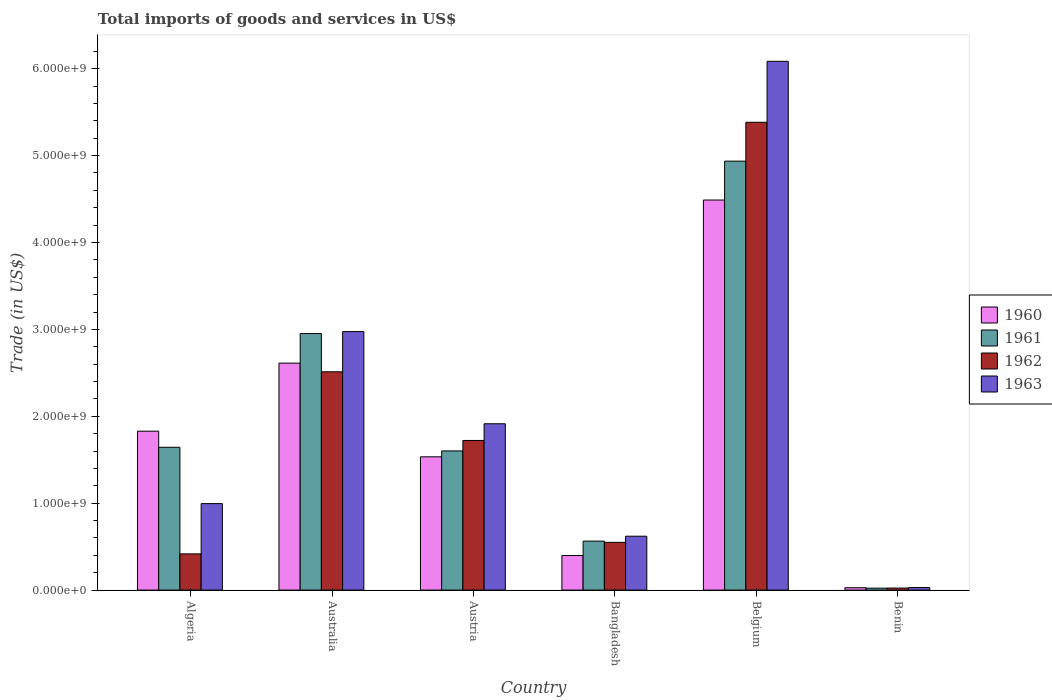How many different coloured bars are there?
Provide a short and direct response. 4. How many bars are there on the 3rd tick from the left?
Offer a very short reply. 4. In how many cases, is the number of bars for a given country not equal to the number of legend labels?
Your answer should be very brief. 0. What is the total imports of goods and services in 1961 in Belgium?
Your answer should be very brief. 4.94e+09. Across all countries, what is the maximum total imports of goods and services in 1960?
Your answer should be compact. 4.49e+09. Across all countries, what is the minimum total imports of goods and services in 1962?
Make the answer very short. 2.35e+07. In which country was the total imports of goods and services in 1963 minimum?
Ensure brevity in your answer.  Benin. What is the total total imports of goods and services in 1962 in the graph?
Provide a succinct answer. 1.06e+1. What is the difference between the total imports of goods and services in 1962 in Austria and that in Bangladesh?
Ensure brevity in your answer.  1.17e+09. What is the difference between the total imports of goods and services in 1962 in Australia and the total imports of goods and services in 1960 in Benin?
Ensure brevity in your answer.  2.48e+09. What is the average total imports of goods and services in 1960 per country?
Provide a succinct answer. 1.81e+09. What is the difference between the total imports of goods and services of/in 1961 and total imports of goods and services of/in 1963 in Austria?
Your answer should be compact. -3.13e+08. In how many countries, is the total imports of goods and services in 1961 greater than 2400000000 US$?
Offer a very short reply. 2. What is the ratio of the total imports of goods and services in 1961 in Bangladesh to that in Benin?
Provide a succinct answer. 25.08. Is the total imports of goods and services in 1960 in Austria less than that in Benin?
Provide a short and direct response. No. Is the difference between the total imports of goods and services in 1961 in Bangladesh and Benin greater than the difference between the total imports of goods and services in 1963 in Bangladesh and Benin?
Keep it short and to the point. No. What is the difference between the highest and the second highest total imports of goods and services in 1961?
Provide a succinct answer. -3.29e+09. What is the difference between the highest and the lowest total imports of goods and services in 1960?
Keep it short and to the point. 4.46e+09. Is the sum of the total imports of goods and services in 1963 in Algeria and Benin greater than the maximum total imports of goods and services in 1960 across all countries?
Keep it short and to the point. No. Is it the case that in every country, the sum of the total imports of goods and services in 1961 and total imports of goods and services in 1960 is greater than the sum of total imports of goods and services in 1962 and total imports of goods and services in 1963?
Your answer should be very brief. No. What does the 4th bar from the left in Australia represents?
Make the answer very short. 1963. How many bars are there?
Make the answer very short. 24. How many countries are there in the graph?
Give a very brief answer. 6. Does the graph contain any zero values?
Offer a very short reply. No. How many legend labels are there?
Offer a terse response. 4. How are the legend labels stacked?
Keep it short and to the point. Vertical. What is the title of the graph?
Your answer should be very brief. Total imports of goods and services in US$. Does "1999" appear as one of the legend labels in the graph?
Offer a very short reply. No. What is the label or title of the Y-axis?
Your answer should be very brief. Trade (in US$). What is the Trade (in US$) in 1960 in Algeria?
Give a very brief answer. 1.83e+09. What is the Trade (in US$) in 1961 in Algeria?
Offer a very short reply. 1.64e+09. What is the Trade (in US$) in 1962 in Algeria?
Provide a short and direct response. 4.17e+08. What is the Trade (in US$) in 1963 in Algeria?
Provide a short and direct response. 9.95e+08. What is the Trade (in US$) in 1960 in Australia?
Your response must be concise. 2.61e+09. What is the Trade (in US$) of 1961 in Australia?
Offer a terse response. 2.95e+09. What is the Trade (in US$) in 1962 in Australia?
Ensure brevity in your answer.  2.51e+09. What is the Trade (in US$) in 1963 in Australia?
Give a very brief answer. 2.97e+09. What is the Trade (in US$) in 1960 in Austria?
Keep it short and to the point. 1.53e+09. What is the Trade (in US$) of 1961 in Austria?
Give a very brief answer. 1.60e+09. What is the Trade (in US$) of 1962 in Austria?
Provide a short and direct response. 1.72e+09. What is the Trade (in US$) of 1963 in Austria?
Make the answer very short. 1.91e+09. What is the Trade (in US$) of 1960 in Bangladesh?
Make the answer very short. 3.98e+08. What is the Trade (in US$) in 1961 in Bangladesh?
Offer a very short reply. 5.64e+08. What is the Trade (in US$) of 1962 in Bangladesh?
Your answer should be compact. 5.49e+08. What is the Trade (in US$) in 1963 in Bangladesh?
Ensure brevity in your answer.  6.20e+08. What is the Trade (in US$) of 1960 in Belgium?
Keep it short and to the point. 4.49e+09. What is the Trade (in US$) in 1961 in Belgium?
Provide a short and direct response. 4.94e+09. What is the Trade (in US$) in 1962 in Belgium?
Offer a very short reply. 5.38e+09. What is the Trade (in US$) in 1963 in Belgium?
Give a very brief answer. 6.08e+09. What is the Trade (in US$) in 1960 in Benin?
Make the answer very short. 2.74e+07. What is the Trade (in US$) in 1961 in Benin?
Offer a very short reply. 2.25e+07. What is the Trade (in US$) of 1962 in Benin?
Your answer should be compact. 2.35e+07. What is the Trade (in US$) in 1963 in Benin?
Your response must be concise. 2.95e+07. Across all countries, what is the maximum Trade (in US$) of 1960?
Offer a very short reply. 4.49e+09. Across all countries, what is the maximum Trade (in US$) in 1961?
Keep it short and to the point. 4.94e+09. Across all countries, what is the maximum Trade (in US$) of 1962?
Provide a short and direct response. 5.38e+09. Across all countries, what is the maximum Trade (in US$) of 1963?
Provide a succinct answer. 6.08e+09. Across all countries, what is the minimum Trade (in US$) of 1960?
Provide a succinct answer. 2.74e+07. Across all countries, what is the minimum Trade (in US$) of 1961?
Give a very brief answer. 2.25e+07. Across all countries, what is the minimum Trade (in US$) of 1962?
Ensure brevity in your answer.  2.35e+07. Across all countries, what is the minimum Trade (in US$) of 1963?
Your answer should be compact. 2.95e+07. What is the total Trade (in US$) of 1960 in the graph?
Provide a short and direct response. 1.09e+1. What is the total Trade (in US$) of 1961 in the graph?
Make the answer very short. 1.17e+1. What is the total Trade (in US$) in 1962 in the graph?
Provide a succinct answer. 1.06e+1. What is the total Trade (in US$) of 1963 in the graph?
Offer a terse response. 1.26e+1. What is the difference between the Trade (in US$) of 1960 in Algeria and that in Australia?
Make the answer very short. -7.83e+08. What is the difference between the Trade (in US$) in 1961 in Algeria and that in Australia?
Your answer should be compact. -1.31e+09. What is the difference between the Trade (in US$) in 1962 in Algeria and that in Australia?
Your answer should be compact. -2.10e+09. What is the difference between the Trade (in US$) of 1963 in Algeria and that in Australia?
Ensure brevity in your answer.  -1.98e+09. What is the difference between the Trade (in US$) in 1960 in Algeria and that in Austria?
Keep it short and to the point. 2.95e+08. What is the difference between the Trade (in US$) in 1961 in Algeria and that in Austria?
Make the answer very short. 4.21e+07. What is the difference between the Trade (in US$) of 1962 in Algeria and that in Austria?
Your answer should be compact. -1.31e+09. What is the difference between the Trade (in US$) in 1963 in Algeria and that in Austria?
Provide a succinct answer. -9.19e+08. What is the difference between the Trade (in US$) in 1960 in Algeria and that in Bangladesh?
Offer a terse response. 1.43e+09. What is the difference between the Trade (in US$) in 1961 in Algeria and that in Bangladesh?
Your answer should be very brief. 1.08e+09. What is the difference between the Trade (in US$) of 1962 in Algeria and that in Bangladesh?
Keep it short and to the point. -1.33e+08. What is the difference between the Trade (in US$) in 1963 in Algeria and that in Bangladesh?
Keep it short and to the point. 3.75e+08. What is the difference between the Trade (in US$) of 1960 in Algeria and that in Belgium?
Provide a short and direct response. -2.66e+09. What is the difference between the Trade (in US$) in 1961 in Algeria and that in Belgium?
Provide a succinct answer. -3.29e+09. What is the difference between the Trade (in US$) of 1962 in Algeria and that in Belgium?
Make the answer very short. -4.97e+09. What is the difference between the Trade (in US$) of 1963 in Algeria and that in Belgium?
Make the answer very short. -5.09e+09. What is the difference between the Trade (in US$) in 1960 in Algeria and that in Benin?
Offer a very short reply. 1.80e+09. What is the difference between the Trade (in US$) of 1961 in Algeria and that in Benin?
Offer a very short reply. 1.62e+09. What is the difference between the Trade (in US$) of 1962 in Algeria and that in Benin?
Provide a succinct answer. 3.93e+08. What is the difference between the Trade (in US$) of 1963 in Algeria and that in Benin?
Your answer should be very brief. 9.66e+08. What is the difference between the Trade (in US$) of 1960 in Australia and that in Austria?
Provide a short and direct response. 1.08e+09. What is the difference between the Trade (in US$) in 1961 in Australia and that in Austria?
Keep it short and to the point. 1.35e+09. What is the difference between the Trade (in US$) in 1962 in Australia and that in Austria?
Your response must be concise. 7.90e+08. What is the difference between the Trade (in US$) of 1963 in Australia and that in Austria?
Offer a very short reply. 1.06e+09. What is the difference between the Trade (in US$) of 1960 in Australia and that in Bangladesh?
Offer a very short reply. 2.21e+09. What is the difference between the Trade (in US$) in 1961 in Australia and that in Bangladesh?
Offer a terse response. 2.39e+09. What is the difference between the Trade (in US$) of 1962 in Australia and that in Bangladesh?
Ensure brevity in your answer.  1.96e+09. What is the difference between the Trade (in US$) of 1963 in Australia and that in Bangladesh?
Provide a short and direct response. 2.35e+09. What is the difference between the Trade (in US$) in 1960 in Australia and that in Belgium?
Offer a very short reply. -1.88e+09. What is the difference between the Trade (in US$) of 1961 in Australia and that in Belgium?
Offer a terse response. -1.98e+09. What is the difference between the Trade (in US$) in 1962 in Australia and that in Belgium?
Offer a terse response. -2.87e+09. What is the difference between the Trade (in US$) of 1963 in Australia and that in Belgium?
Offer a terse response. -3.11e+09. What is the difference between the Trade (in US$) in 1960 in Australia and that in Benin?
Your answer should be compact. 2.58e+09. What is the difference between the Trade (in US$) in 1961 in Australia and that in Benin?
Your response must be concise. 2.93e+09. What is the difference between the Trade (in US$) of 1962 in Australia and that in Benin?
Keep it short and to the point. 2.49e+09. What is the difference between the Trade (in US$) of 1963 in Australia and that in Benin?
Offer a terse response. 2.95e+09. What is the difference between the Trade (in US$) in 1960 in Austria and that in Bangladesh?
Your response must be concise. 1.14e+09. What is the difference between the Trade (in US$) of 1961 in Austria and that in Bangladesh?
Offer a terse response. 1.04e+09. What is the difference between the Trade (in US$) in 1962 in Austria and that in Bangladesh?
Your response must be concise. 1.17e+09. What is the difference between the Trade (in US$) of 1963 in Austria and that in Bangladesh?
Your answer should be very brief. 1.29e+09. What is the difference between the Trade (in US$) of 1960 in Austria and that in Belgium?
Ensure brevity in your answer.  -2.96e+09. What is the difference between the Trade (in US$) in 1961 in Austria and that in Belgium?
Offer a very short reply. -3.33e+09. What is the difference between the Trade (in US$) of 1962 in Austria and that in Belgium?
Make the answer very short. -3.66e+09. What is the difference between the Trade (in US$) in 1963 in Austria and that in Belgium?
Offer a terse response. -4.17e+09. What is the difference between the Trade (in US$) of 1960 in Austria and that in Benin?
Provide a short and direct response. 1.51e+09. What is the difference between the Trade (in US$) of 1961 in Austria and that in Benin?
Your response must be concise. 1.58e+09. What is the difference between the Trade (in US$) of 1962 in Austria and that in Benin?
Provide a short and direct response. 1.70e+09. What is the difference between the Trade (in US$) in 1963 in Austria and that in Benin?
Make the answer very short. 1.88e+09. What is the difference between the Trade (in US$) in 1960 in Bangladesh and that in Belgium?
Offer a very short reply. -4.09e+09. What is the difference between the Trade (in US$) of 1961 in Bangladesh and that in Belgium?
Your response must be concise. -4.37e+09. What is the difference between the Trade (in US$) of 1962 in Bangladesh and that in Belgium?
Give a very brief answer. -4.83e+09. What is the difference between the Trade (in US$) of 1963 in Bangladesh and that in Belgium?
Give a very brief answer. -5.46e+09. What is the difference between the Trade (in US$) of 1960 in Bangladesh and that in Benin?
Provide a short and direct response. 3.70e+08. What is the difference between the Trade (in US$) in 1961 in Bangladesh and that in Benin?
Your answer should be compact. 5.41e+08. What is the difference between the Trade (in US$) of 1962 in Bangladesh and that in Benin?
Offer a terse response. 5.26e+08. What is the difference between the Trade (in US$) of 1963 in Bangladesh and that in Benin?
Provide a succinct answer. 5.91e+08. What is the difference between the Trade (in US$) of 1960 in Belgium and that in Benin?
Give a very brief answer. 4.46e+09. What is the difference between the Trade (in US$) of 1961 in Belgium and that in Benin?
Your answer should be very brief. 4.91e+09. What is the difference between the Trade (in US$) in 1962 in Belgium and that in Benin?
Provide a short and direct response. 5.36e+09. What is the difference between the Trade (in US$) of 1963 in Belgium and that in Benin?
Your response must be concise. 6.06e+09. What is the difference between the Trade (in US$) in 1960 in Algeria and the Trade (in US$) in 1961 in Australia?
Provide a succinct answer. -1.12e+09. What is the difference between the Trade (in US$) of 1960 in Algeria and the Trade (in US$) of 1962 in Australia?
Keep it short and to the point. -6.83e+08. What is the difference between the Trade (in US$) of 1960 in Algeria and the Trade (in US$) of 1963 in Australia?
Offer a very short reply. -1.15e+09. What is the difference between the Trade (in US$) in 1961 in Algeria and the Trade (in US$) in 1962 in Australia?
Offer a very short reply. -8.68e+08. What is the difference between the Trade (in US$) in 1961 in Algeria and the Trade (in US$) in 1963 in Australia?
Make the answer very short. -1.33e+09. What is the difference between the Trade (in US$) in 1962 in Algeria and the Trade (in US$) in 1963 in Australia?
Offer a terse response. -2.56e+09. What is the difference between the Trade (in US$) of 1960 in Algeria and the Trade (in US$) of 1961 in Austria?
Make the answer very short. 2.27e+08. What is the difference between the Trade (in US$) of 1960 in Algeria and the Trade (in US$) of 1962 in Austria?
Offer a very short reply. 1.07e+08. What is the difference between the Trade (in US$) in 1960 in Algeria and the Trade (in US$) in 1963 in Austria?
Ensure brevity in your answer.  -8.54e+07. What is the difference between the Trade (in US$) of 1961 in Algeria and the Trade (in US$) of 1962 in Austria?
Provide a short and direct response. -7.84e+07. What is the difference between the Trade (in US$) in 1961 in Algeria and the Trade (in US$) in 1963 in Austria?
Keep it short and to the point. -2.71e+08. What is the difference between the Trade (in US$) of 1962 in Algeria and the Trade (in US$) of 1963 in Austria?
Ensure brevity in your answer.  -1.50e+09. What is the difference between the Trade (in US$) of 1960 in Algeria and the Trade (in US$) of 1961 in Bangladesh?
Offer a very short reply. 1.27e+09. What is the difference between the Trade (in US$) of 1960 in Algeria and the Trade (in US$) of 1962 in Bangladesh?
Your response must be concise. 1.28e+09. What is the difference between the Trade (in US$) in 1960 in Algeria and the Trade (in US$) in 1963 in Bangladesh?
Provide a short and direct response. 1.21e+09. What is the difference between the Trade (in US$) in 1961 in Algeria and the Trade (in US$) in 1962 in Bangladesh?
Give a very brief answer. 1.09e+09. What is the difference between the Trade (in US$) of 1961 in Algeria and the Trade (in US$) of 1963 in Bangladesh?
Keep it short and to the point. 1.02e+09. What is the difference between the Trade (in US$) in 1962 in Algeria and the Trade (in US$) in 1963 in Bangladesh?
Give a very brief answer. -2.03e+08. What is the difference between the Trade (in US$) in 1960 in Algeria and the Trade (in US$) in 1961 in Belgium?
Offer a very short reply. -3.11e+09. What is the difference between the Trade (in US$) of 1960 in Algeria and the Trade (in US$) of 1962 in Belgium?
Offer a very short reply. -3.55e+09. What is the difference between the Trade (in US$) in 1960 in Algeria and the Trade (in US$) in 1963 in Belgium?
Give a very brief answer. -4.26e+09. What is the difference between the Trade (in US$) of 1961 in Algeria and the Trade (in US$) of 1962 in Belgium?
Offer a terse response. -3.74e+09. What is the difference between the Trade (in US$) of 1961 in Algeria and the Trade (in US$) of 1963 in Belgium?
Provide a short and direct response. -4.44e+09. What is the difference between the Trade (in US$) in 1962 in Algeria and the Trade (in US$) in 1963 in Belgium?
Make the answer very short. -5.67e+09. What is the difference between the Trade (in US$) in 1960 in Algeria and the Trade (in US$) in 1961 in Benin?
Your response must be concise. 1.81e+09. What is the difference between the Trade (in US$) in 1960 in Algeria and the Trade (in US$) in 1962 in Benin?
Offer a very short reply. 1.81e+09. What is the difference between the Trade (in US$) of 1960 in Algeria and the Trade (in US$) of 1963 in Benin?
Offer a very short reply. 1.80e+09. What is the difference between the Trade (in US$) in 1961 in Algeria and the Trade (in US$) in 1962 in Benin?
Ensure brevity in your answer.  1.62e+09. What is the difference between the Trade (in US$) in 1961 in Algeria and the Trade (in US$) in 1963 in Benin?
Provide a short and direct response. 1.61e+09. What is the difference between the Trade (in US$) of 1962 in Algeria and the Trade (in US$) of 1963 in Benin?
Offer a very short reply. 3.87e+08. What is the difference between the Trade (in US$) in 1960 in Australia and the Trade (in US$) in 1961 in Austria?
Offer a very short reply. 1.01e+09. What is the difference between the Trade (in US$) in 1960 in Australia and the Trade (in US$) in 1962 in Austria?
Give a very brief answer. 8.90e+08. What is the difference between the Trade (in US$) in 1960 in Australia and the Trade (in US$) in 1963 in Austria?
Your answer should be compact. 6.98e+08. What is the difference between the Trade (in US$) in 1961 in Australia and the Trade (in US$) in 1962 in Austria?
Your answer should be compact. 1.23e+09. What is the difference between the Trade (in US$) of 1961 in Australia and the Trade (in US$) of 1963 in Austria?
Keep it short and to the point. 1.04e+09. What is the difference between the Trade (in US$) in 1962 in Australia and the Trade (in US$) in 1963 in Austria?
Your answer should be very brief. 5.98e+08. What is the difference between the Trade (in US$) in 1960 in Australia and the Trade (in US$) in 1961 in Bangladesh?
Make the answer very short. 2.05e+09. What is the difference between the Trade (in US$) in 1960 in Australia and the Trade (in US$) in 1962 in Bangladesh?
Offer a terse response. 2.06e+09. What is the difference between the Trade (in US$) in 1960 in Australia and the Trade (in US$) in 1963 in Bangladesh?
Offer a terse response. 1.99e+09. What is the difference between the Trade (in US$) of 1961 in Australia and the Trade (in US$) of 1962 in Bangladesh?
Offer a very short reply. 2.40e+09. What is the difference between the Trade (in US$) of 1961 in Australia and the Trade (in US$) of 1963 in Bangladesh?
Your answer should be compact. 2.33e+09. What is the difference between the Trade (in US$) in 1962 in Australia and the Trade (in US$) in 1963 in Bangladesh?
Provide a succinct answer. 1.89e+09. What is the difference between the Trade (in US$) of 1960 in Australia and the Trade (in US$) of 1961 in Belgium?
Offer a very short reply. -2.32e+09. What is the difference between the Trade (in US$) in 1960 in Australia and the Trade (in US$) in 1962 in Belgium?
Ensure brevity in your answer.  -2.77e+09. What is the difference between the Trade (in US$) of 1960 in Australia and the Trade (in US$) of 1963 in Belgium?
Give a very brief answer. -3.47e+09. What is the difference between the Trade (in US$) of 1961 in Australia and the Trade (in US$) of 1962 in Belgium?
Your answer should be compact. -2.43e+09. What is the difference between the Trade (in US$) in 1961 in Australia and the Trade (in US$) in 1963 in Belgium?
Your answer should be compact. -3.13e+09. What is the difference between the Trade (in US$) in 1962 in Australia and the Trade (in US$) in 1963 in Belgium?
Keep it short and to the point. -3.57e+09. What is the difference between the Trade (in US$) of 1960 in Australia and the Trade (in US$) of 1961 in Benin?
Your answer should be compact. 2.59e+09. What is the difference between the Trade (in US$) of 1960 in Australia and the Trade (in US$) of 1962 in Benin?
Your response must be concise. 2.59e+09. What is the difference between the Trade (in US$) of 1960 in Australia and the Trade (in US$) of 1963 in Benin?
Offer a terse response. 2.58e+09. What is the difference between the Trade (in US$) in 1961 in Australia and the Trade (in US$) in 1962 in Benin?
Ensure brevity in your answer.  2.93e+09. What is the difference between the Trade (in US$) in 1961 in Australia and the Trade (in US$) in 1963 in Benin?
Your answer should be very brief. 2.92e+09. What is the difference between the Trade (in US$) in 1962 in Australia and the Trade (in US$) in 1963 in Benin?
Your answer should be very brief. 2.48e+09. What is the difference between the Trade (in US$) in 1960 in Austria and the Trade (in US$) in 1961 in Bangladesh?
Your answer should be compact. 9.70e+08. What is the difference between the Trade (in US$) in 1960 in Austria and the Trade (in US$) in 1962 in Bangladesh?
Keep it short and to the point. 9.84e+08. What is the difference between the Trade (in US$) of 1960 in Austria and the Trade (in US$) of 1963 in Bangladesh?
Your response must be concise. 9.14e+08. What is the difference between the Trade (in US$) in 1961 in Austria and the Trade (in US$) in 1962 in Bangladesh?
Offer a very short reply. 1.05e+09. What is the difference between the Trade (in US$) of 1961 in Austria and the Trade (in US$) of 1963 in Bangladesh?
Your answer should be very brief. 9.81e+08. What is the difference between the Trade (in US$) in 1962 in Austria and the Trade (in US$) in 1963 in Bangladesh?
Your answer should be very brief. 1.10e+09. What is the difference between the Trade (in US$) of 1960 in Austria and the Trade (in US$) of 1961 in Belgium?
Offer a terse response. -3.40e+09. What is the difference between the Trade (in US$) in 1960 in Austria and the Trade (in US$) in 1962 in Belgium?
Your answer should be very brief. -3.85e+09. What is the difference between the Trade (in US$) of 1960 in Austria and the Trade (in US$) of 1963 in Belgium?
Keep it short and to the point. -4.55e+09. What is the difference between the Trade (in US$) in 1961 in Austria and the Trade (in US$) in 1962 in Belgium?
Keep it short and to the point. -3.78e+09. What is the difference between the Trade (in US$) in 1961 in Austria and the Trade (in US$) in 1963 in Belgium?
Provide a succinct answer. -4.48e+09. What is the difference between the Trade (in US$) in 1962 in Austria and the Trade (in US$) in 1963 in Belgium?
Keep it short and to the point. -4.36e+09. What is the difference between the Trade (in US$) in 1960 in Austria and the Trade (in US$) in 1961 in Benin?
Offer a terse response. 1.51e+09. What is the difference between the Trade (in US$) of 1960 in Austria and the Trade (in US$) of 1962 in Benin?
Your answer should be compact. 1.51e+09. What is the difference between the Trade (in US$) of 1960 in Austria and the Trade (in US$) of 1963 in Benin?
Your answer should be very brief. 1.50e+09. What is the difference between the Trade (in US$) in 1961 in Austria and the Trade (in US$) in 1962 in Benin?
Ensure brevity in your answer.  1.58e+09. What is the difference between the Trade (in US$) in 1961 in Austria and the Trade (in US$) in 1963 in Benin?
Offer a terse response. 1.57e+09. What is the difference between the Trade (in US$) of 1962 in Austria and the Trade (in US$) of 1963 in Benin?
Your answer should be compact. 1.69e+09. What is the difference between the Trade (in US$) in 1960 in Bangladesh and the Trade (in US$) in 1961 in Belgium?
Offer a very short reply. -4.54e+09. What is the difference between the Trade (in US$) of 1960 in Bangladesh and the Trade (in US$) of 1962 in Belgium?
Ensure brevity in your answer.  -4.99e+09. What is the difference between the Trade (in US$) in 1960 in Bangladesh and the Trade (in US$) in 1963 in Belgium?
Offer a terse response. -5.69e+09. What is the difference between the Trade (in US$) of 1961 in Bangladesh and the Trade (in US$) of 1962 in Belgium?
Your answer should be compact. -4.82e+09. What is the difference between the Trade (in US$) of 1961 in Bangladesh and the Trade (in US$) of 1963 in Belgium?
Offer a very short reply. -5.52e+09. What is the difference between the Trade (in US$) in 1962 in Bangladesh and the Trade (in US$) in 1963 in Belgium?
Your answer should be compact. -5.54e+09. What is the difference between the Trade (in US$) in 1960 in Bangladesh and the Trade (in US$) in 1961 in Benin?
Give a very brief answer. 3.75e+08. What is the difference between the Trade (in US$) in 1960 in Bangladesh and the Trade (in US$) in 1962 in Benin?
Make the answer very short. 3.74e+08. What is the difference between the Trade (in US$) of 1960 in Bangladesh and the Trade (in US$) of 1963 in Benin?
Your answer should be very brief. 3.68e+08. What is the difference between the Trade (in US$) of 1961 in Bangladesh and the Trade (in US$) of 1962 in Benin?
Offer a very short reply. 5.40e+08. What is the difference between the Trade (in US$) of 1961 in Bangladesh and the Trade (in US$) of 1963 in Benin?
Keep it short and to the point. 5.34e+08. What is the difference between the Trade (in US$) of 1962 in Bangladesh and the Trade (in US$) of 1963 in Benin?
Offer a terse response. 5.20e+08. What is the difference between the Trade (in US$) in 1960 in Belgium and the Trade (in US$) in 1961 in Benin?
Offer a terse response. 4.47e+09. What is the difference between the Trade (in US$) in 1960 in Belgium and the Trade (in US$) in 1962 in Benin?
Your response must be concise. 4.47e+09. What is the difference between the Trade (in US$) in 1960 in Belgium and the Trade (in US$) in 1963 in Benin?
Ensure brevity in your answer.  4.46e+09. What is the difference between the Trade (in US$) of 1961 in Belgium and the Trade (in US$) of 1962 in Benin?
Your response must be concise. 4.91e+09. What is the difference between the Trade (in US$) of 1961 in Belgium and the Trade (in US$) of 1963 in Benin?
Make the answer very short. 4.91e+09. What is the difference between the Trade (in US$) of 1962 in Belgium and the Trade (in US$) of 1963 in Benin?
Offer a terse response. 5.35e+09. What is the average Trade (in US$) of 1960 per country?
Your response must be concise. 1.81e+09. What is the average Trade (in US$) in 1961 per country?
Your answer should be very brief. 1.95e+09. What is the average Trade (in US$) of 1962 per country?
Your response must be concise. 1.77e+09. What is the average Trade (in US$) in 1963 per country?
Provide a short and direct response. 2.10e+09. What is the difference between the Trade (in US$) of 1960 and Trade (in US$) of 1961 in Algeria?
Your answer should be compact. 1.85e+08. What is the difference between the Trade (in US$) in 1960 and Trade (in US$) in 1962 in Algeria?
Ensure brevity in your answer.  1.41e+09. What is the difference between the Trade (in US$) of 1960 and Trade (in US$) of 1963 in Algeria?
Your answer should be compact. 8.33e+08. What is the difference between the Trade (in US$) of 1961 and Trade (in US$) of 1962 in Algeria?
Provide a succinct answer. 1.23e+09. What is the difference between the Trade (in US$) in 1961 and Trade (in US$) in 1963 in Algeria?
Offer a terse response. 6.48e+08. What is the difference between the Trade (in US$) in 1962 and Trade (in US$) in 1963 in Algeria?
Make the answer very short. -5.79e+08. What is the difference between the Trade (in US$) in 1960 and Trade (in US$) in 1961 in Australia?
Offer a very short reply. -3.40e+08. What is the difference between the Trade (in US$) of 1960 and Trade (in US$) of 1962 in Australia?
Give a very brief answer. 9.97e+07. What is the difference between the Trade (in US$) in 1960 and Trade (in US$) in 1963 in Australia?
Provide a short and direct response. -3.63e+08. What is the difference between the Trade (in US$) in 1961 and Trade (in US$) in 1962 in Australia?
Keep it short and to the point. 4.40e+08. What is the difference between the Trade (in US$) in 1961 and Trade (in US$) in 1963 in Australia?
Offer a terse response. -2.24e+07. What is the difference between the Trade (in US$) in 1962 and Trade (in US$) in 1963 in Australia?
Your answer should be very brief. -4.63e+08. What is the difference between the Trade (in US$) in 1960 and Trade (in US$) in 1961 in Austria?
Keep it short and to the point. -6.78e+07. What is the difference between the Trade (in US$) in 1960 and Trade (in US$) in 1962 in Austria?
Your response must be concise. -1.88e+08. What is the difference between the Trade (in US$) of 1960 and Trade (in US$) of 1963 in Austria?
Your answer should be very brief. -3.81e+08. What is the difference between the Trade (in US$) of 1961 and Trade (in US$) of 1962 in Austria?
Your answer should be very brief. -1.21e+08. What is the difference between the Trade (in US$) in 1961 and Trade (in US$) in 1963 in Austria?
Your answer should be very brief. -3.13e+08. What is the difference between the Trade (in US$) in 1962 and Trade (in US$) in 1963 in Austria?
Keep it short and to the point. -1.92e+08. What is the difference between the Trade (in US$) of 1960 and Trade (in US$) of 1961 in Bangladesh?
Make the answer very short. -1.66e+08. What is the difference between the Trade (in US$) of 1960 and Trade (in US$) of 1962 in Bangladesh?
Offer a terse response. -1.51e+08. What is the difference between the Trade (in US$) in 1960 and Trade (in US$) in 1963 in Bangladesh?
Your answer should be very brief. -2.22e+08. What is the difference between the Trade (in US$) of 1961 and Trade (in US$) of 1962 in Bangladesh?
Provide a short and direct response. 1.45e+07. What is the difference between the Trade (in US$) in 1961 and Trade (in US$) in 1963 in Bangladesh?
Your answer should be very brief. -5.64e+07. What is the difference between the Trade (in US$) of 1962 and Trade (in US$) of 1963 in Bangladesh?
Make the answer very short. -7.08e+07. What is the difference between the Trade (in US$) in 1960 and Trade (in US$) in 1961 in Belgium?
Provide a succinct answer. -4.47e+08. What is the difference between the Trade (in US$) of 1960 and Trade (in US$) of 1962 in Belgium?
Your answer should be very brief. -8.94e+08. What is the difference between the Trade (in US$) in 1960 and Trade (in US$) in 1963 in Belgium?
Provide a short and direct response. -1.60e+09. What is the difference between the Trade (in US$) in 1961 and Trade (in US$) in 1962 in Belgium?
Provide a short and direct response. -4.47e+08. What is the difference between the Trade (in US$) in 1961 and Trade (in US$) in 1963 in Belgium?
Your answer should be compact. -1.15e+09. What is the difference between the Trade (in US$) in 1962 and Trade (in US$) in 1963 in Belgium?
Offer a very short reply. -7.02e+08. What is the difference between the Trade (in US$) in 1960 and Trade (in US$) in 1961 in Benin?
Your response must be concise. 4.92e+06. What is the difference between the Trade (in US$) in 1960 and Trade (in US$) in 1962 in Benin?
Provide a short and direct response. 3.85e+06. What is the difference between the Trade (in US$) in 1960 and Trade (in US$) in 1963 in Benin?
Make the answer very short. -2.13e+06. What is the difference between the Trade (in US$) in 1961 and Trade (in US$) in 1962 in Benin?
Keep it short and to the point. -1.08e+06. What is the difference between the Trade (in US$) of 1961 and Trade (in US$) of 1963 in Benin?
Keep it short and to the point. -7.05e+06. What is the difference between the Trade (in US$) of 1962 and Trade (in US$) of 1963 in Benin?
Your answer should be compact. -5.97e+06. What is the ratio of the Trade (in US$) of 1960 in Algeria to that in Australia?
Provide a short and direct response. 0.7. What is the ratio of the Trade (in US$) in 1961 in Algeria to that in Australia?
Offer a very short reply. 0.56. What is the ratio of the Trade (in US$) of 1962 in Algeria to that in Australia?
Give a very brief answer. 0.17. What is the ratio of the Trade (in US$) in 1963 in Algeria to that in Australia?
Keep it short and to the point. 0.33. What is the ratio of the Trade (in US$) in 1960 in Algeria to that in Austria?
Your answer should be very brief. 1.19. What is the ratio of the Trade (in US$) in 1961 in Algeria to that in Austria?
Make the answer very short. 1.03. What is the ratio of the Trade (in US$) of 1962 in Algeria to that in Austria?
Offer a terse response. 0.24. What is the ratio of the Trade (in US$) in 1963 in Algeria to that in Austria?
Give a very brief answer. 0.52. What is the ratio of the Trade (in US$) in 1960 in Algeria to that in Bangladesh?
Provide a succinct answer. 4.6. What is the ratio of the Trade (in US$) of 1961 in Algeria to that in Bangladesh?
Provide a short and direct response. 2.92. What is the ratio of the Trade (in US$) of 1962 in Algeria to that in Bangladesh?
Provide a short and direct response. 0.76. What is the ratio of the Trade (in US$) in 1963 in Algeria to that in Bangladesh?
Ensure brevity in your answer.  1.61. What is the ratio of the Trade (in US$) of 1960 in Algeria to that in Belgium?
Offer a very short reply. 0.41. What is the ratio of the Trade (in US$) of 1961 in Algeria to that in Belgium?
Keep it short and to the point. 0.33. What is the ratio of the Trade (in US$) of 1962 in Algeria to that in Belgium?
Keep it short and to the point. 0.08. What is the ratio of the Trade (in US$) of 1963 in Algeria to that in Belgium?
Your answer should be very brief. 0.16. What is the ratio of the Trade (in US$) in 1960 in Algeria to that in Benin?
Offer a terse response. 66.76. What is the ratio of the Trade (in US$) of 1961 in Algeria to that in Benin?
Ensure brevity in your answer.  73.14. What is the ratio of the Trade (in US$) of 1962 in Algeria to that in Benin?
Your answer should be compact. 17.7. What is the ratio of the Trade (in US$) in 1963 in Algeria to that in Benin?
Your answer should be very brief. 33.72. What is the ratio of the Trade (in US$) in 1960 in Australia to that in Austria?
Give a very brief answer. 1.7. What is the ratio of the Trade (in US$) of 1961 in Australia to that in Austria?
Offer a very short reply. 1.84. What is the ratio of the Trade (in US$) of 1962 in Australia to that in Austria?
Your answer should be compact. 1.46. What is the ratio of the Trade (in US$) in 1963 in Australia to that in Austria?
Keep it short and to the point. 1.55. What is the ratio of the Trade (in US$) in 1960 in Australia to that in Bangladesh?
Ensure brevity in your answer.  6.56. What is the ratio of the Trade (in US$) of 1961 in Australia to that in Bangladesh?
Keep it short and to the point. 5.24. What is the ratio of the Trade (in US$) of 1962 in Australia to that in Bangladesh?
Offer a very short reply. 4.57. What is the ratio of the Trade (in US$) in 1963 in Australia to that in Bangladesh?
Your answer should be compact. 4.8. What is the ratio of the Trade (in US$) in 1960 in Australia to that in Belgium?
Keep it short and to the point. 0.58. What is the ratio of the Trade (in US$) in 1961 in Australia to that in Belgium?
Your answer should be very brief. 0.6. What is the ratio of the Trade (in US$) in 1962 in Australia to that in Belgium?
Keep it short and to the point. 0.47. What is the ratio of the Trade (in US$) of 1963 in Australia to that in Belgium?
Provide a succinct answer. 0.49. What is the ratio of the Trade (in US$) in 1960 in Australia to that in Benin?
Offer a terse response. 95.34. What is the ratio of the Trade (in US$) in 1961 in Australia to that in Benin?
Your response must be concise. 131.38. What is the ratio of the Trade (in US$) in 1962 in Australia to that in Benin?
Keep it short and to the point. 106.68. What is the ratio of the Trade (in US$) in 1963 in Australia to that in Benin?
Provide a succinct answer. 100.76. What is the ratio of the Trade (in US$) in 1960 in Austria to that in Bangladesh?
Ensure brevity in your answer.  3.85. What is the ratio of the Trade (in US$) in 1961 in Austria to that in Bangladesh?
Your response must be concise. 2.84. What is the ratio of the Trade (in US$) in 1962 in Austria to that in Bangladesh?
Offer a terse response. 3.14. What is the ratio of the Trade (in US$) of 1963 in Austria to that in Bangladesh?
Offer a very short reply. 3.09. What is the ratio of the Trade (in US$) in 1960 in Austria to that in Belgium?
Your answer should be compact. 0.34. What is the ratio of the Trade (in US$) of 1961 in Austria to that in Belgium?
Your answer should be compact. 0.32. What is the ratio of the Trade (in US$) in 1962 in Austria to that in Belgium?
Offer a terse response. 0.32. What is the ratio of the Trade (in US$) in 1963 in Austria to that in Belgium?
Offer a terse response. 0.31. What is the ratio of the Trade (in US$) of 1960 in Austria to that in Benin?
Give a very brief answer. 55.98. What is the ratio of the Trade (in US$) of 1961 in Austria to that in Benin?
Provide a short and direct response. 71.27. What is the ratio of the Trade (in US$) in 1962 in Austria to that in Benin?
Provide a succinct answer. 73.13. What is the ratio of the Trade (in US$) of 1963 in Austria to that in Benin?
Your answer should be compact. 64.84. What is the ratio of the Trade (in US$) of 1960 in Bangladesh to that in Belgium?
Your answer should be compact. 0.09. What is the ratio of the Trade (in US$) in 1961 in Bangladesh to that in Belgium?
Give a very brief answer. 0.11. What is the ratio of the Trade (in US$) of 1962 in Bangladesh to that in Belgium?
Ensure brevity in your answer.  0.1. What is the ratio of the Trade (in US$) of 1963 in Bangladesh to that in Belgium?
Your answer should be very brief. 0.1. What is the ratio of the Trade (in US$) of 1960 in Bangladesh to that in Benin?
Your answer should be compact. 14.52. What is the ratio of the Trade (in US$) of 1961 in Bangladesh to that in Benin?
Your answer should be very brief. 25.08. What is the ratio of the Trade (in US$) in 1962 in Bangladesh to that in Benin?
Provide a short and direct response. 23.32. What is the ratio of the Trade (in US$) of 1963 in Bangladesh to that in Benin?
Your response must be concise. 21. What is the ratio of the Trade (in US$) of 1960 in Belgium to that in Benin?
Keep it short and to the point. 163.86. What is the ratio of the Trade (in US$) in 1961 in Belgium to that in Benin?
Make the answer very short. 219.67. What is the ratio of the Trade (in US$) of 1962 in Belgium to that in Benin?
Provide a succinct answer. 228.61. What is the ratio of the Trade (in US$) of 1963 in Belgium to that in Benin?
Your answer should be compact. 206.11. What is the difference between the highest and the second highest Trade (in US$) in 1960?
Your answer should be very brief. 1.88e+09. What is the difference between the highest and the second highest Trade (in US$) in 1961?
Offer a very short reply. 1.98e+09. What is the difference between the highest and the second highest Trade (in US$) of 1962?
Provide a short and direct response. 2.87e+09. What is the difference between the highest and the second highest Trade (in US$) of 1963?
Provide a short and direct response. 3.11e+09. What is the difference between the highest and the lowest Trade (in US$) in 1960?
Offer a terse response. 4.46e+09. What is the difference between the highest and the lowest Trade (in US$) of 1961?
Provide a short and direct response. 4.91e+09. What is the difference between the highest and the lowest Trade (in US$) of 1962?
Provide a short and direct response. 5.36e+09. What is the difference between the highest and the lowest Trade (in US$) in 1963?
Ensure brevity in your answer.  6.06e+09. 